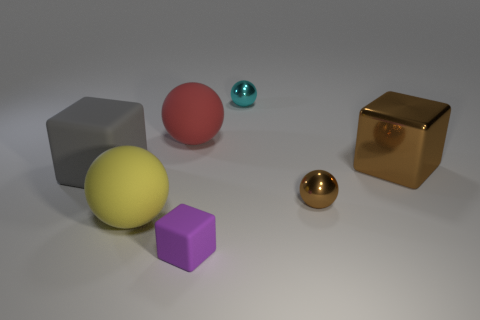What shapes and colors can you identify in this image? In this image, there are several distinct shapes and colors. On the left, there's a large grey cube and a small purple cube. In the center, there is a yellow sphere, and to the right, you can see a red sphere, a small teal sphere, and a reflective brown sphere. Additionally, there's a reflective brown cube on the far right. 